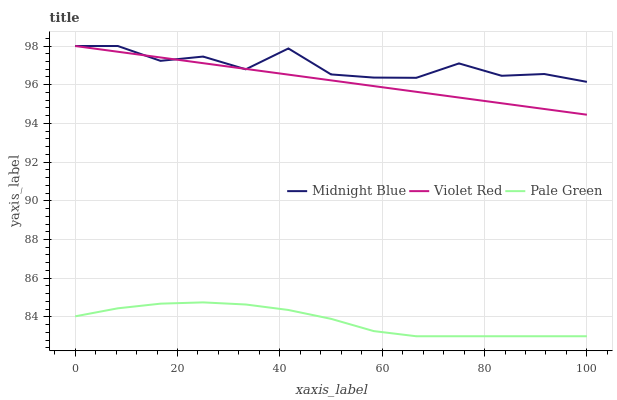Does Pale Green have the minimum area under the curve?
Answer yes or no. Yes. Does Midnight Blue have the maximum area under the curve?
Answer yes or no. Yes. Does Midnight Blue have the minimum area under the curve?
Answer yes or no. No. Does Pale Green have the maximum area under the curve?
Answer yes or no. No. Is Violet Red the smoothest?
Answer yes or no. Yes. Is Midnight Blue the roughest?
Answer yes or no. Yes. Is Pale Green the smoothest?
Answer yes or no. No. Is Pale Green the roughest?
Answer yes or no. No. Does Midnight Blue have the lowest value?
Answer yes or no. No. Does Midnight Blue have the highest value?
Answer yes or no. Yes. Does Pale Green have the highest value?
Answer yes or no. No. Is Pale Green less than Violet Red?
Answer yes or no. Yes. Is Violet Red greater than Pale Green?
Answer yes or no. Yes. Does Midnight Blue intersect Violet Red?
Answer yes or no. Yes. Is Midnight Blue less than Violet Red?
Answer yes or no. No. Is Midnight Blue greater than Violet Red?
Answer yes or no. No. Does Pale Green intersect Violet Red?
Answer yes or no. No. 